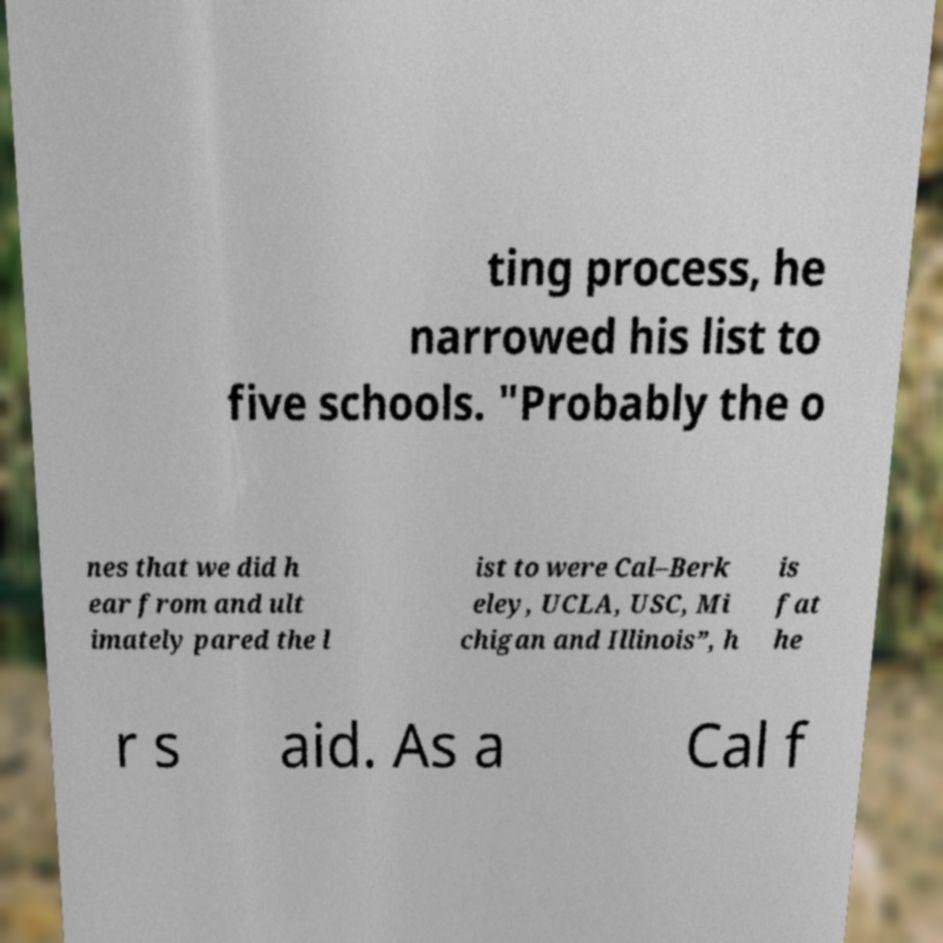Please read and relay the text visible in this image. What does it say? ting process, he narrowed his list to five schools. "Probably the o nes that we did h ear from and ult imately pared the l ist to were Cal–Berk eley, UCLA, USC, Mi chigan and Illinois”, h is fat he r s aid. As a Cal f 